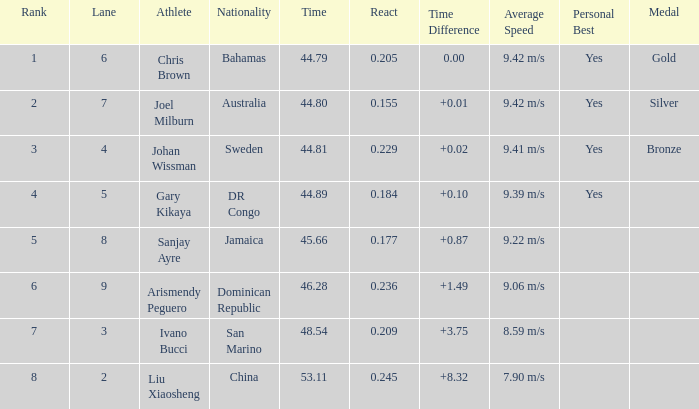What is the total average for Rank entries where the Lane listed is smaller than 4 and the Nationality listed is San Marino? 7.0. Would you mind parsing the complete table? {'header': ['Rank', 'Lane', 'Athlete', 'Nationality', 'Time', 'React', 'Time Difference', 'Average Speed', 'Personal Best', 'Medal'], 'rows': [['1', '6', 'Chris Brown', 'Bahamas', '44.79', '0.205', '0.00', '9.42 m/s', 'Yes', 'Gold'], ['2', '7', 'Joel Milburn', 'Australia', '44.80', '0.155', '+0.01', '9.42 m/s', 'Yes', 'Silver'], ['3', '4', 'Johan Wissman', 'Sweden', '44.81', '0.229', '+0.02', '9.41 m/s', 'Yes', 'Bronze'], ['4', '5', 'Gary Kikaya', 'DR Congo', '44.89', '0.184', '+0.10', '9.39 m/s', 'Yes', ''], ['5', '8', 'Sanjay Ayre', 'Jamaica', '45.66', '0.177', '+0.87', '9.22 m/s', '', ''], ['6', '9', 'Arismendy Peguero', 'Dominican Republic', '46.28', '0.236', '+1.49', '9.06 m/s', '', ''], ['7', '3', 'Ivano Bucci', 'San Marino', '48.54', '0.209', '+3.75', '8.59 m/s', '', ''], ['8', '2', 'Liu Xiaosheng', 'China', '53.11', '0.245', '+8.32', '7.90 m/s', '', '']]} 